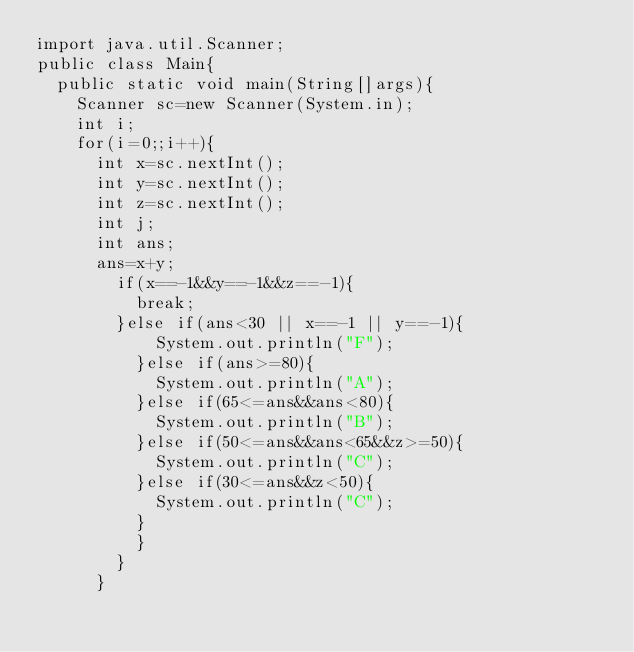<code> <loc_0><loc_0><loc_500><loc_500><_Java_>import java.util.Scanner;
public class Main{
	public static void main(String[]args){
		Scanner sc=new Scanner(System.in);
		int i;
		for(i=0;;i++){
			int x=sc.nextInt();
			int y=sc.nextInt();
			int z=sc.nextInt();
			int j;
			int ans;
			ans=x+y;
				if(x==-1&&y==-1&&z==-1){
					break;
				}else if(ans<30 || x==-1 || y==-1){
						System.out.println("F");
					}else if(ans>=80){
						System.out.println("A");
					}else if(65<=ans&&ans<80){
						System.out.println("B");
					}else if(50<=ans&&ans<65&&z>=50){
						System.out.println("C");
					}else if(30<=ans&&z<50){
						System.out.println("C");
					}
					}
				}
			}</code> 